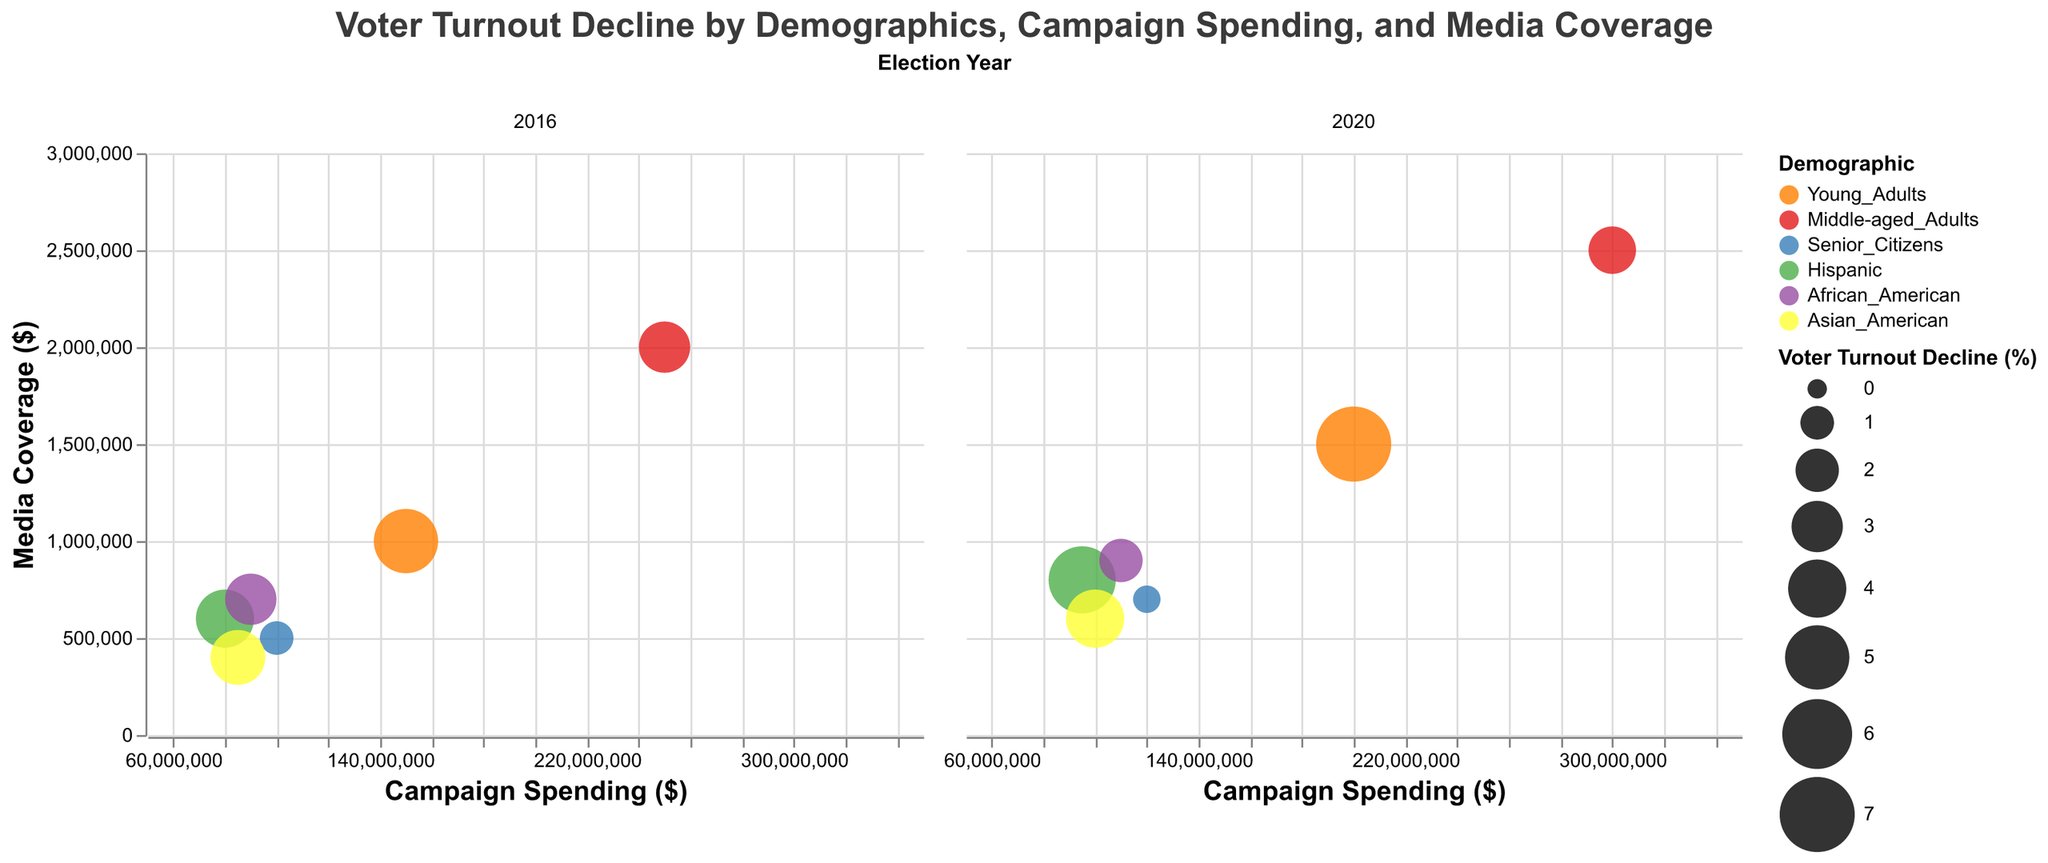What is the title of the figure? The title of the figure is displayed at the top and is usually centered. The figure shows "Voter Turnout Decline by Demographics, Campaign Spending, and Media Coverage".
Answer: "Voter Turnout Decline by Demographics, Campaign Spending, and Media Coverage" Which demographic group had the highest voter turnout decline in 2020? By examining the size of the bubbles in the 2020 column, we can see that Young Adults have the largest bubble, indicating the highest voter turnout decline.
Answer: Young Adults What is the media coverage for African American voters in 2016? By locating the African American bubble in the 2016 column, we see the corresponding y-axis value for media coverage. It is 700,000.
Answer: $700,000 Which demographic experienced a decrease in voter turnout decline from 2016 to 2020? Comparing the bubble sizes for each demographic group across the two years, we see that Middle-aged Adults, Senior Citizens, and African Americans experienced a decrease.
Answer: Middle-aged Adults, Senior Citizens, and African Americans What is the range of campaign spending displayed on the x-axis? The range of campaign spending displayed on the x-axis spans from $50,000,000 to $350,000,000.
Answer: $50,000,000 to $350,000,000 How did the voter turnout decline for Senior Citizens change from 2016 to 2020? Looking at the bubble sizes for Senior Citizens, it's evident that the bubble size decreased, indicating a decline in voter turnout decline from 1% in 2016 to 0.5% in 2020.
Answer: Decreased from 1% to 0.5% Which demographic had the least media coverage in 2016? By observing the smallest bubble located lowest on the y-axis in 2016, we identify that Asian Americans had the least media coverage of $400,000.
Answer: Asian Americans Compare the campaign spending for Hispancis and Young Adults in 2020. Which had higher spending? By looking at the bubbles for Hispanic and Young Adults in the 2020 column, Hispanic had a spending of $95,000,000, and Young Adults spent $200,000,000. So, Young Adults had higher spending.
Answer: Young Adults What is the voter turnout decline for Asian Americans in 2020? The size of the bubble for Asian Americans in the 2020 column indicates a voter turnout decline value of 4%.
Answer: 4% Which group shows the highest voter turnout decline despite relatively lower media coverage in 2020? By cross-referencing the bubble sizes with their media coverage values in 2020, we find that Hispanics show a significant voter turnout decline of 5.5% with moderate media coverage of $800,000.
Answer: Hispanic 